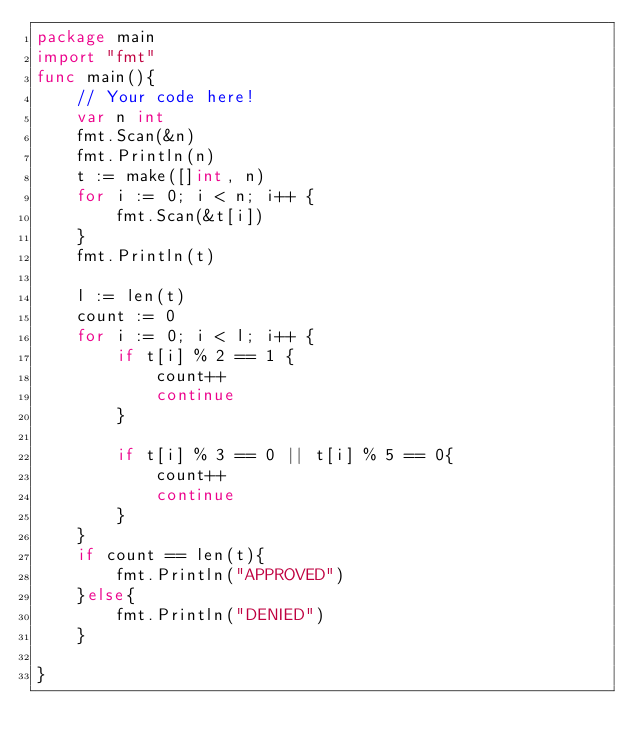Convert code to text. <code><loc_0><loc_0><loc_500><loc_500><_Go_>package main
import "fmt"
func main(){
    // Your code here!
    var n int
    fmt.Scan(&n)
    fmt.Println(n)
    t := make([]int, n)
    for i := 0; i < n; i++ {
        fmt.Scan(&t[i])
    }
    fmt.Println(t)
    
    l := len(t)
    count := 0
    for i := 0; i < l; i++ {
        if t[i] % 2 == 1 {
            count++
            continue
        }
        
        if t[i] % 3 == 0 || t[i] % 5 == 0{
            count++
            continue
        }
    }
    if count == len(t){
        fmt.Println("APPROVED")
    }else{
        fmt.Println("DENIED")
    }
    
}</code> 